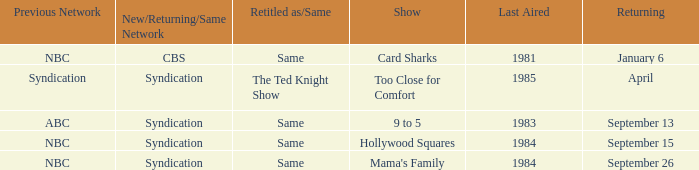What was the earliest aired show that's returning on September 13? 1983.0. Can you give me this table as a dict? {'header': ['Previous Network', 'New/Returning/Same Network', 'Retitled as/Same', 'Show', 'Last Aired', 'Returning'], 'rows': [['NBC', 'CBS', 'Same', 'Card Sharks', '1981', 'January 6'], ['Syndication', 'Syndication', 'The Ted Knight Show', 'Too Close for Comfort', '1985', 'April'], ['ABC', 'Syndication', 'Same', '9 to 5', '1983', 'September 13'], ['NBC', 'Syndication', 'Same', 'Hollywood Squares', '1984', 'September 15'], ['NBC', 'Syndication', 'Same', "Mama's Family", '1984', 'September 26']]} 